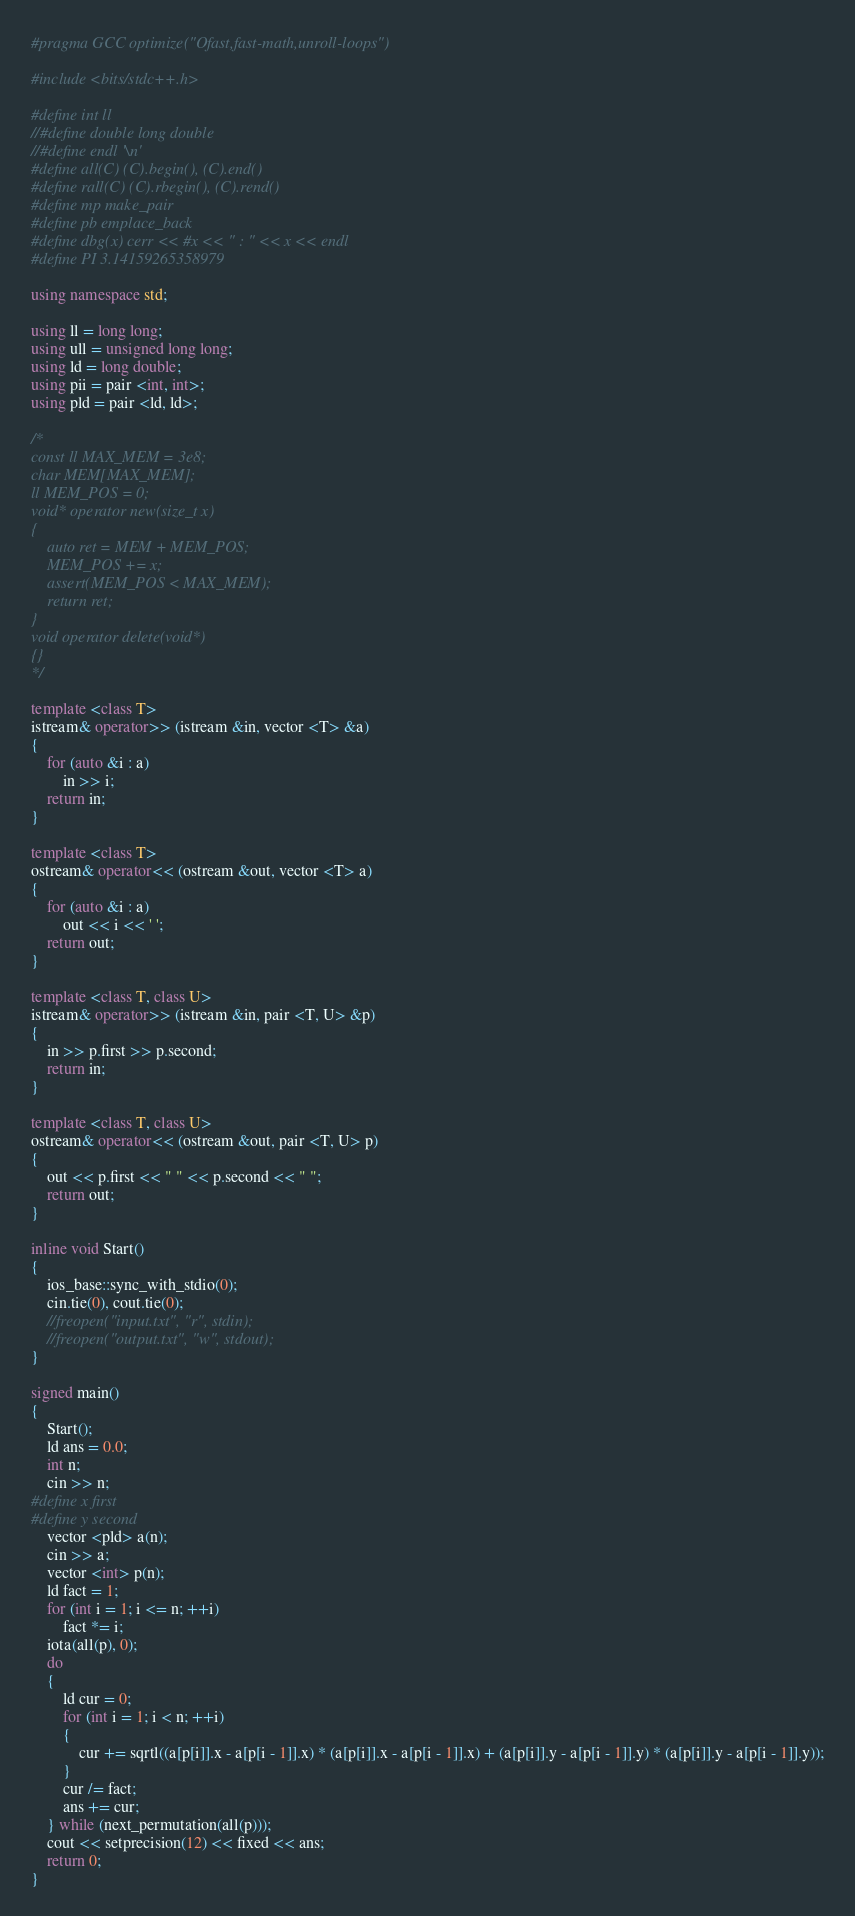Convert code to text. <code><loc_0><loc_0><loc_500><loc_500><_C++_>#pragma GCC optimize("Ofast,fast-math,unroll-loops")

#include <bits/stdc++.h>

#define int ll
//#define double long double
//#define endl '\n'
#define all(C) (C).begin(), (C).end()
#define rall(C) (C).rbegin(), (C).rend()
#define mp make_pair
#define pb emplace_back
#define dbg(x) cerr << #x << " : " << x << endl
#define PI 3.14159265358979

using namespace std;

using ll = long long;
using ull = unsigned long long;
using ld = long double;
using pii = pair <int, int>;
using pld = pair <ld, ld>;

/*
const ll MAX_MEM = 3e8;
char MEM[MAX_MEM];
ll MEM_POS = 0;
void* operator new(size_t x)
{
    auto ret = MEM + MEM_POS;
    MEM_POS += x;
    assert(MEM_POS < MAX_MEM);
    return ret;
}
void operator delete(void*)
{}
*/

template <class T>
istream& operator>> (istream &in, vector <T> &a)
{
    for (auto &i : a)
        in >> i;
    return in;
}

template <class T>
ostream& operator<< (ostream &out, vector <T> a)
{
    for (auto &i : a)
        out << i << ' ';
    return out;
}

template <class T, class U>
istream& operator>> (istream &in, pair <T, U> &p)
{
    in >> p.first >> p.second;
    return in;
}

template <class T, class U>
ostream& operator<< (ostream &out, pair <T, U> p)
{
    out << p.first << " " << p.second << " ";
    return out;
}

inline void Start()
{
    ios_base::sync_with_stdio(0);
    cin.tie(0), cout.tie(0);
    //freopen("input.txt", "r", stdin);
    //freopen("output.txt", "w", stdout);
}

signed main()
{
    Start();
    ld ans = 0.0;
    int n;
    cin >> n;
#define x first
#define y second
    vector <pld> a(n);
    cin >> a;
    vector <int> p(n);
    ld fact = 1;
    for (int i = 1; i <= n; ++i)
        fact *= i;
    iota(all(p), 0);
    do
    {
        ld cur = 0;
        for (int i = 1; i < n; ++i)
        {
            cur += sqrtl((a[p[i]].x - a[p[i - 1]].x) * (a[p[i]].x - a[p[i - 1]].x) + (a[p[i]].y - a[p[i - 1]].y) * (a[p[i]].y - a[p[i - 1]].y));
        }
        cur /= fact;
        ans += cur;
    } while (next_permutation(all(p)));
    cout << setprecision(12) << fixed << ans;
    return 0;
}


</code> 